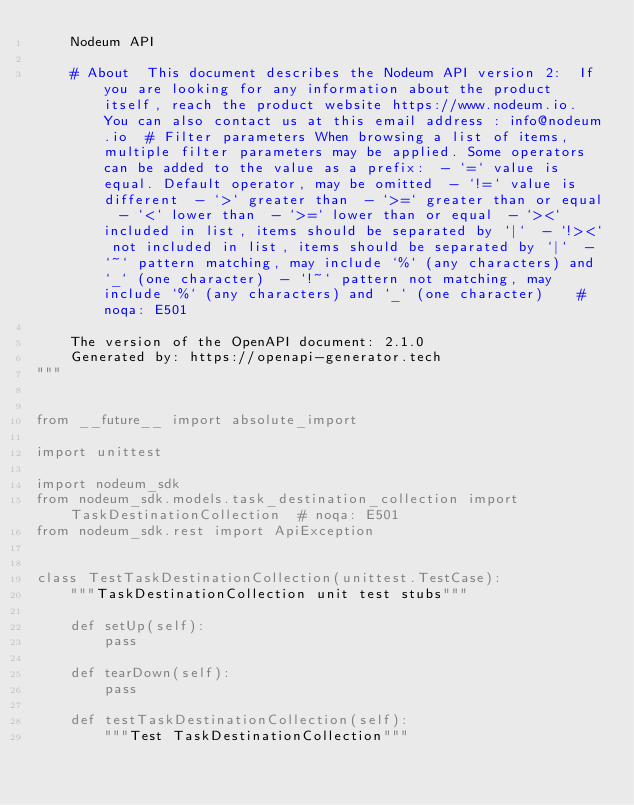<code> <loc_0><loc_0><loc_500><loc_500><_Python_>    Nodeum API

    # About  This document describes the Nodeum API version 2:  If you are looking for any information about the product itself, reach the product website https://www.nodeum.io. You can also contact us at this email address : info@nodeum.io  # Filter parameters When browsing a list of items, multiple filter parameters may be applied. Some operators can be added to the value as a prefix:  - `=` value is equal. Default operator, may be omitted  - `!=` value is different  - `>` greater than  - `>=` greater than or equal  - `<` lower than  - `>=` lower than or equal  - `><` included in list, items should be separated by `|`  - `!><` not included in list, items should be separated by `|`  - `~` pattern matching, may include `%` (any characters) and `_` (one character)  - `!~` pattern not matching, may include `%` (any characters) and `_` (one character)    # noqa: E501

    The version of the OpenAPI document: 2.1.0
    Generated by: https://openapi-generator.tech
"""


from __future__ import absolute_import

import unittest

import nodeum_sdk
from nodeum_sdk.models.task_destination_collection import TaskDestinationCollection  # noqa: E501
from nodeum_sdk.rest import ApiException


class TestTaskDestinationCollection(unittest.TestCase):
    """TaskDestinationCollection unit test stubs"""

    def setUp(self):
        pass

    def tearDown(self):
        pass

    def testTaskDestinationCollection(self):
        """Test TaskDestinationCollection"""</code> 